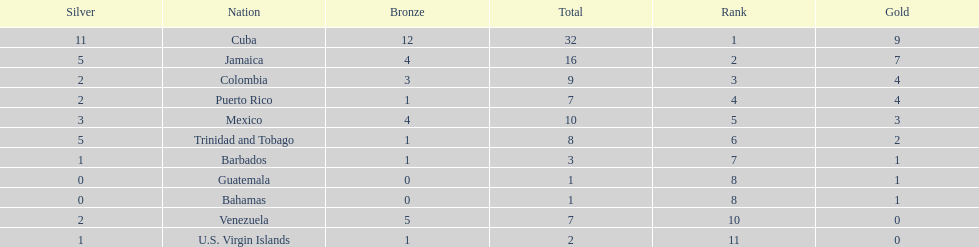Nations that had 10 or more medals each Cuba, Jamaica, Mexico. 